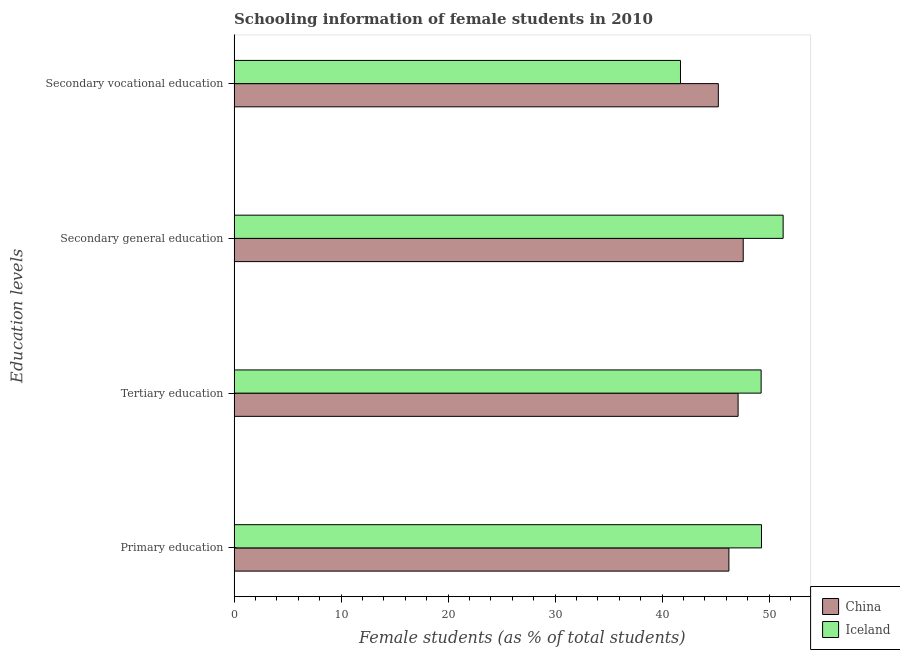How many different coloured bars are there?
Offer a very short reply. 2. How many groups of bars are there?
Provide a short and direct response. 4. Are the number of bars per tick equal to the number of legend labels?
Your answer should be compact. Yes. Are the number of bars on each tick of the Y-axis equal?
Make the answer very short. Yes. How many bars are there on the 1st tick from the top?
Ensure brevity in your answer.  2. What is the label of the 2nd group of bars from the top?
Your answer should be compact. Secondary general education. What is the percentage of female students in secondary education in Iceland?
Offer a terse response. 51.31. Across all countries, what is the maximum percentage of female students in tertiary education?
Keep it short and to the point. 49.25. Across all countries, what is the minimum percentage of female students in primary education?
Provide a short and direct response. 46.24. In which country was the percentage of female students in primary education maximum?
Provide a short and direct response. Iceland. What is the total percentage of female students in secondary education in the graph?
Provide a short and direct response. 98.88. What is the difference between the percentage of female students in primary education in Iceland and that in China?
Provide a succinct answer. 3.05. What is the difference between the percentage of female students in secondary vocational education in China and the percentage of female students in primary education in Iceland?
Your response must be concise. -4.03. What is the average percentage of female students in secondary vocational education per country?
Your response must be concise. 43.48. What is the difference between the percentage of female students in tertiary education and percentage of female students in secondary education in China?
Your answer should be compact. -0.48. What is the ratio of the percentage of female students in tertiary education in China to that in Iceland?
Your response must be concise. 0.96. Is the difference between the percentage of female students in secondary education in Iceland and China greater than the difference between the percentage of female students in secondary vocational education in Iceland and China?
Make the answer very short. Yes. What is the difference between the highest and the second highest percentage of female students in primary education?
Make the answer very short. 3.05. What is the difference between the highest and the lowest percentage of female students in secondary education?
Offer a very short reply. 3.73. What does the 1st bar from the top in Secondary vocational education represents?
Give a very brief answer. Iceland. What does the 2nd bar from the bottom in Secondary general education represents?
Your response must be concise. Iceland. Is it the case that in every country, the sum of the percentage of female students in primary education and percentage of female students in tertiary education is greater than the percentage of female students in secondary education?
Keep it short and to the point. Yes. How many bars are there?
Offer a terse response. 8. Are all the bars in the graph horizontal?
Offer a terse response. Yes. Does the graph contain any zero values?
Keep it short and to the point. No. Does the graph contain grids?
Your response must be concise. No. How are the legend labels stacked?
Your response must be concise. Vertical. What is the title of the graph?
Provide a succinct answer. Schooling information of female students in 2010. What is the label or title of the X-axis?
Offer a very short reply. Female students (as % of total students). What is the label or title of the Y-axis?
Give a very brief answer. Education levels. What is the Female students (as % of total students) of China in Primary education?
Your response must be concise. 46.24. What is the Female students (as % of total students) in Iceland in Primary education?
Provide a short and direct response. 49.28. What is the Female students (as % of total students) of China in Tertiary education?
Your response must be concise. 47.1. What is the Female students (as % of total students) of Iceland in Tertiary education?
Your response must be concise. 49.25. What is the Female students (as % of total students) in China in Secondary general education?
Offer a very short reply. 47.58. What is the Female students (as % of total students) of Iceland in Secondary general education?
Keep it short and to the point. 51.31. What is the Female students (as % of total students) in China in Secondary vocational education?
Your answer should be compact. 45.25. What is the Female students (as % of total students) of Iceland in Secondary vocational education?
Provide a succinct answer. 41.71. Across all Education levels, what is the maximum Female students (as % of total students) of China?
Provide a short and direct response. 47.58. Across all Education levels, what is the maximum Female students (as % of total students) in Iceland?
Give a very brief answer. 51.31. Across all Education levels, what is the minimum Female students (as % of total students) of China?
Give a very brief answer. 45.25. Across all Education levels, what is the minimum Female students (as % of total students) in Iceland?
Your response must be concise. 41.71. What is the total Female students (as % of total students) of China in the graph?
Your response must be concise. 186.16. What is the total Female students (as % of total students) in Iceland in the graph?
Make the answer very short. 191.55. What is the difference between the Female students (as % of total students) in China in Primary education and that in Tertiary education?
Your answer should be compact. -0.86. What is the difference between the Female students (as % of total students) of Iceland in Primary education and that in Tertiary education?
Offer a very short reply. 0.03. What is the difference between the Female students (as % of total students) of China in Primary education and that in Secondary general education?
Provide a succinct answer. -1.34. What is the difference between the Female students (as % of total students) of Iceland in Primary education and that in Secondary general education?
Your answer should be very brief. -2.02. What is the difference between the Female students (as % of total students) of China in Primary education and that in Secondary vocational education?
Offer a very short reply. 0.99. What is the difference between the Female students (as % of total students) in Iceland in Primary education and that in Secondary vocational education?
Your answer should be compact. 7.57. What is the difference between the Female students (as % of total students) of China in Tertiary education and that in Secondary general education?
Your answer should be very brief. -0.48. What is the difference between the Female students (as % of total students) of Iceland in Tertiary education and that in Secondary general education?
Offer a terse response. -2.06. What is the difference between the Female students (as % of total students) in China in Tertiary education and that in Secondary vocational education?
Provide a short and direct response. 1.85. What is the difference between the Female students (as % of total students) of Iceland in Tertiary education and that in Secondary vocational education?
Keep it short and to the point. 7.54. What is the difference between the Female students (as % of total students) in China in Secondary general education and that in Secondary vocational education?
Make the answer very short. 2.33. What is the difference between the Female students (as % of total students) in Iceland in Secondary general education and that in Secondary vocational education?
Your answer should be compact. 9.59. What is the difference between the Female students (as % of total students) of China in Primary education and the Female students (as % of total students) of Iceland in Tertiary education?
Give a very brief answer. -3.01. What is the difference between the Female students (as % of total students) of China in Primary education and the Female students (as % of total students) of Iceland in Secondary general education?
Your response must be concise. -5.07. What is the difference between the Female students (as % of total students) of China in Primary education and the Female students (as % of total students) of Iceland in Secondary vocational education?
Your answer should be very brief. 4.52. What is the difference between the Female students (as % of total students) of China in Tertiary education and the Female students (as % of total students) of Iceland in Secondary general education?
Ensure brevity in your answer.  -4.21. What is the difference between the Female students (as % of total students) in China in Tertiary education and the Female students (as % of total students) in Iceland in Secondary vocational education?
Your answer should be compact. 5.38. What is the difference between the Female students (as % of total students) in China in Secondary general education and the Female students (as % of total students) in Iceland in Secondary vocational education?
Provide a short and direct response. 5.86. What is the average Female students (as % of total students) of China per Education levels?
Your answer should be very brief. 46.54. What is the average Female students (as % of total students) in Iceland per Education levels?
Offer a terse response. 47.89. What is the difference between the Female students (as % of total students) of China and Female students (as % of total students) of Iceland in Primary education?
Make the answer very short. -3.05. What is the difference between the Female students (as % of total students) of China and Female students (as % of total students) of Iceland in Tertiary education?
Offer a terse response. -2.15. What is the difference between the Female students (as % of total students) in China and Female students (as % of total students) in Iceland in Secondary general education?
Offer a terse response. -3.73. What is the difference between the Female students (as % of total students) in China and Female students (as % of total students) in Iceland in Secondary vocational education?
Your answer should be compact. 3.54. What is the ratio of the Female students (as % of total students) in China in Primary education to that in Tertiary education?
Your answer should be compact. 0.98. What is the ratio of the Female students (as % of total students) of China in Primary education to that in Secondary general education?
Provide a short and direct response. 0.97. What is the ratio of the Female students (as % of total students) of Iceland in Primary education to that in Secondary general education?
Give a very brief answer. 0.96. What is the ratio of the Female students (as % of total students) in China in Primary education to that in Secondary vocational education?
Make the answer very short. 1.02. What is the ratio of the Female students (as % of total students) in Iceland in Primary education to that in Secondary vocational education?
Give a very brief answer. 1.18. What is the ratio of the Female students (as % of total students) in China in Tertiary education to that in Secondary general education?
Make the answer very short. 0.99. What is the ratio of the Female students (as % of total students) of Iceland in Tertiary education to that in Secondary general education?
Provide a short and direct response. 0.96. What is the ratio of the Female students (as % of total students) of China in Tertiary education to that in Secondary vocational education?
Keep it short and to the point. 1.04. What is the ratio of the Female students (as % of total students) in Iceland in Tertiary education to that in Secondary vocational education?
Your response must be concise. 1.18. What is the ratio of the Female students (as % of total students) of China in Secondary general education to that in Secondary vocational education?
Offer a terse response. 1.05. What is the ratio of the Female students (as % of total students) in Iceland in Secondary general education to that in Secondary vocational education?
Provide a succinct answer. 1.23. What is the difference between the highest and the second highest Female students (as % of total students) of China?
Your response must be concise. 0.48. What is the difference between the highest and the second highest Female students (as % of total students) in Iceland?
Provide a succinct answer. 2.02. What is the difference between the highest and the lowest Female students (as % of total students) of China?
Your answer should be compact. 2.33. What is the difference between the highest and the lowest Female students (as % of total students) of Iceland?
Your answer should be compact. 9.59. 